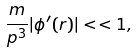Convert formula to latex. <formula><loc_0><loc_0><loc_500><loc_500>\frac { m } { p ^ { 3 } } | \phi ^ { \prime } ( r ) | < < 1 ,</formula> 